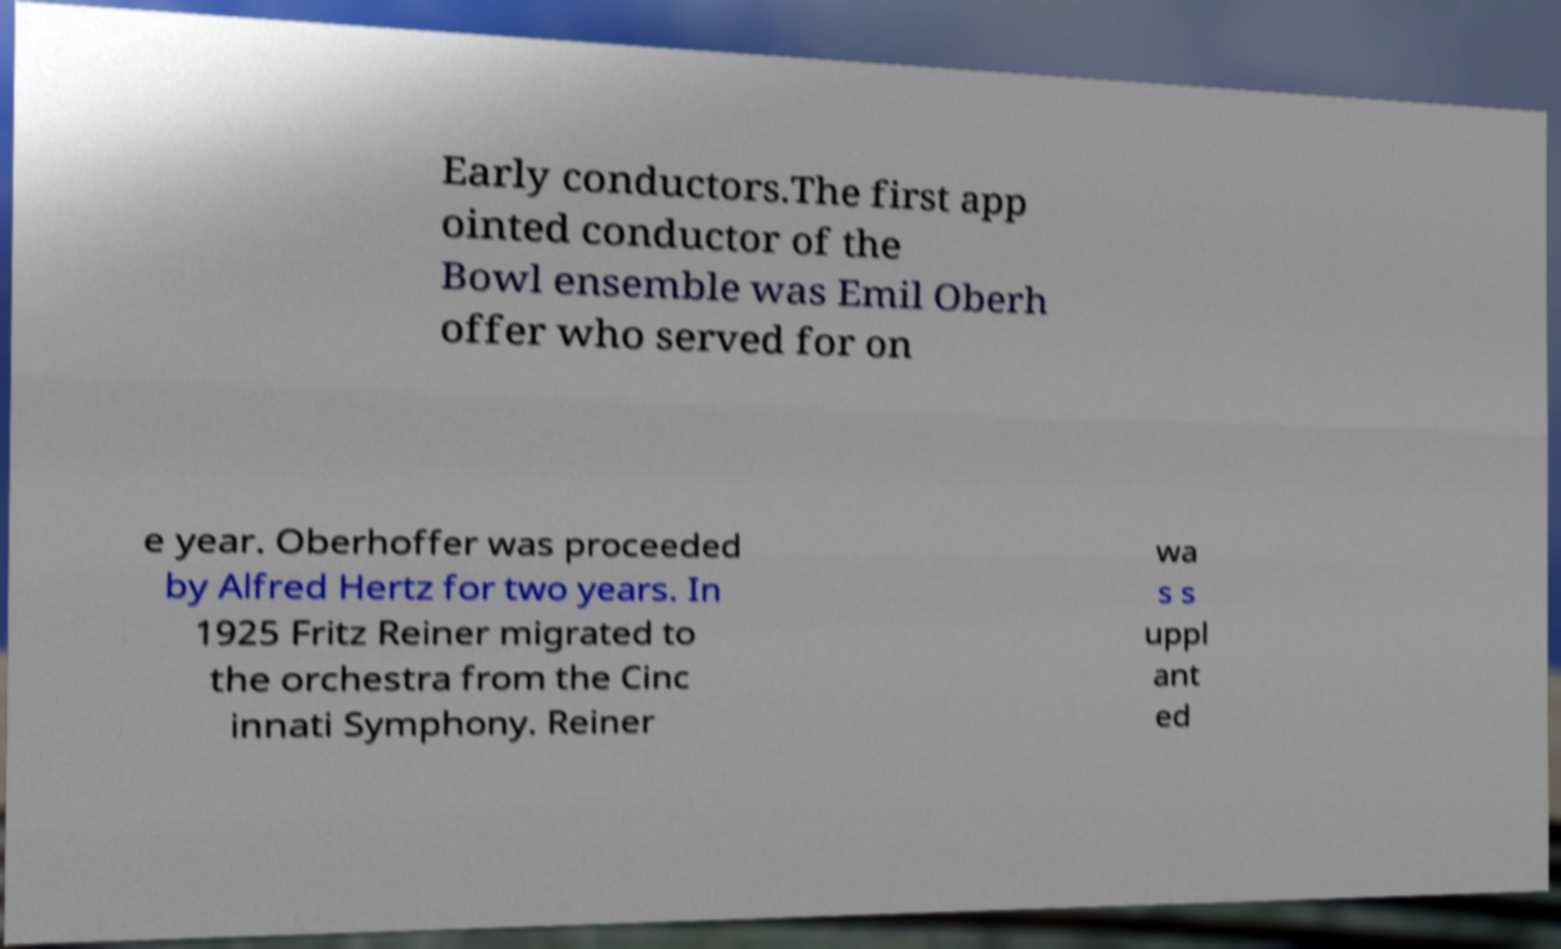Can you accurately transcribe the text from the provided image for me? Early conductors.The first app ointed conductor of the Bowl ensemble was Emil Oberh offer who served for on e year. Oberhoffer was proceeded by Alfred Hertz for two years. In 1925 Fritz Reiner migrated to the orchestra from the Cinc innati Symphony. Reiner wa s s uppl ant ed 